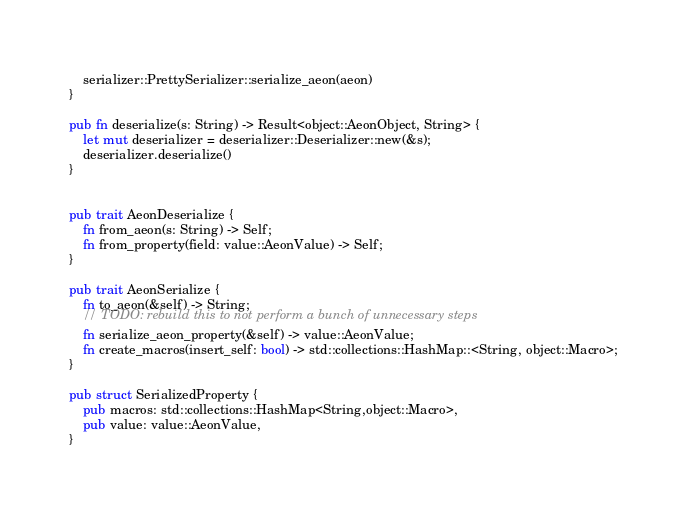Convert code to text. <code><loc_0><loc_0><loc_500><loc_500><_Rust_>    serializer::PrettySerializer::serialize_aeon(aeon)
}

pub fn deserialize(s: String) -> Result<object::AeonObject, String> {
    let mut deserializer = deserializer::Deserializer::new(&s);
    deserializer.deserialize()
}


pub trait AeonDeserialize {
    fn from_aeon(s: String) -> Self;
    fn from_property(field: value::AeonValue) -> Self;
}

pub trait AeonSerialize {
    fn to_aeon(&self) -> String;
    // TODO: rebuild this to not perform a bunch of unnecessary steps
    fn serialize_aeon_property(&self) -> value::AeonValue;
    fn create_macros(insert_self: bool) -> std::collections::HashMap::<String, object::Macro>;
}

pub struct SerializedProperty {
    pub macros: std::collections::HashMap<String,object::Macro>,
    pub value: value::AeonValue,
}

</code> 